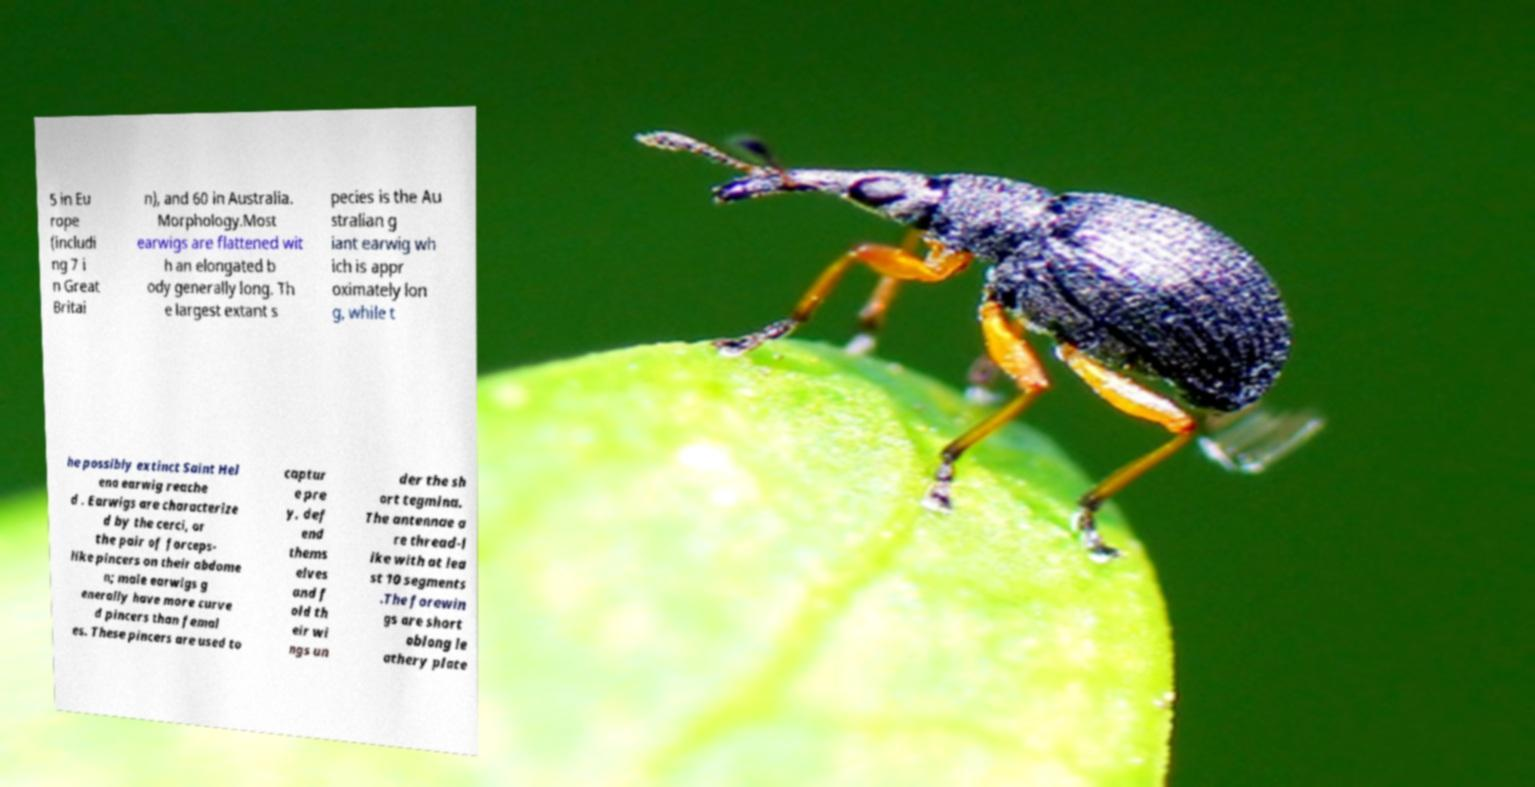Please identify and transcribe the text found in this image. 5 in Eu rope (includi ng 7 i n Great Britai n), and 60 in Australia. Morphology.Most earwigs are flattened wit h an elongated b ody generally long. Th e largest extant s pecies is the Au stralian g iant earwig wh ich is appr oximately lon g, while t he possibly extinct Saint Hel ena earwig reache d . Earwigs are characterize d by the cerci, or the pair of forceps- like pincers on their abdome n; male earwigs g enerally have more curve d pincers than femal es. These pincers are used to captur e pre y, def end thems elves and f old th eir wi ngs un der the sh ort tegmina. The antennae a re thread-l ike with at lea st 10 segments .The forewin gs are short oblong le athery plate 